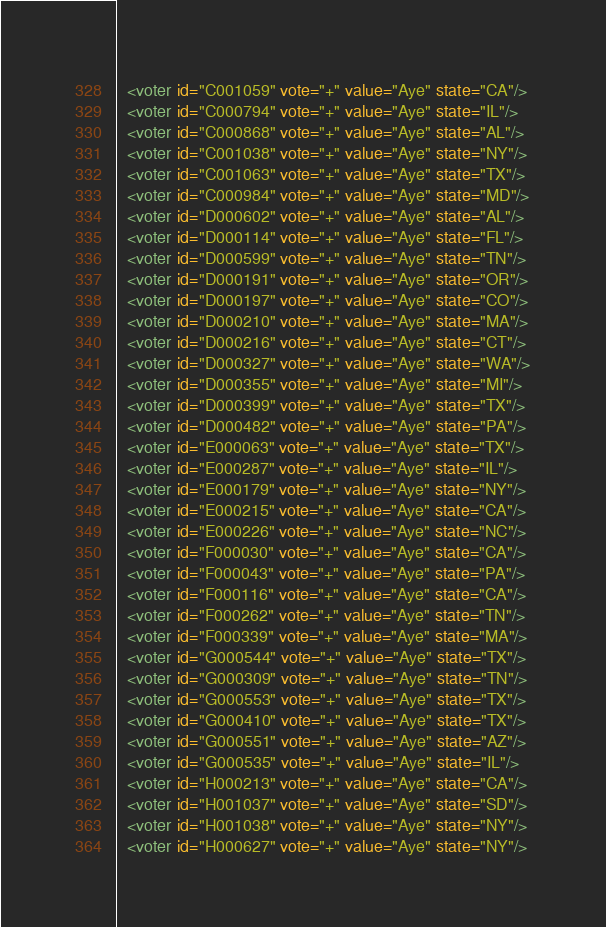Convert code to text. <code><loc_0><loc_0><loc_500><loc_500><_XML_>  <voter id="C001059" vote="+" value="Aye" state="CA"/>
  <voter id="C000794" vote="+" value="Aye" state="IL"/>
  <voter id="C000868" vote="+" value="Aye" state="AL"/>
  <voter id="C001038" vote="+" value="Aye" state="NY"/>
  <voter id="C001063" vote="+" value="Aye" state="TX"/>
  <voter id="C000984" vote="+" value="Aye" state="MD"/>
  <voter id="D000602" vote="+" value="Aye" state="AL"/>
  <voter id="D000114" vote="+" value="Aye" state="FL"/>
  <voter id="D000599" vote="+" value="Aye" state="TN"/>
  <voter id="D000191" vote="+" value="Aye" state="OR"/>
  <voter id="D000197" vote="+" value="Aye" state="CO"/>
  <voter id="D000210" vote="+" value="Aye" state="MA"/>
  <voter id="D000216" vote="+" value="Aye" state="CT"/>
  <voter id="D000327" vote="+" value="Aye" state="WA"/>
  <voter id="D000355" vote="+" value="Aye" state="MI"/>
  <voter id="D000399" vote="+" value="Aye" state="TX"/>
  <voter id="D000482" vote="+" value="Aye" state="PA"/>
  <voter id="E000063" vote="+" value="Aye" state="TX"/>
  <voter id="E000287" vote="+" value="Aye" state="IL"/>
  <voter id="E000179" vote="+" value="Aye" state="NY"/>
  <voter id="E000215" vote="+" value="Aye" state="CA"/>
  <voter id="E000226" vote="+" value="Aye" state="NC"/>
  <voter id="F000030" vote="+" value="Aye" state="CA"/>
  <voter id="F000043" vote="+" value="Aye" state="PA"/>
  <voter id="F000116" vote="+" value="Aye" state="CA"/>
  <voter id="F000262" vote="+" value="Aye" state="TN"/>
  <voter id="F000339" vote="+" value="Aye" state="MA"/>
  <voter id="G000544" vote="+" value="Aye" state="TX"/>
  <voter id="G000309" vote="+" value="Aye" state="TN"/>
  <voter id="G000553" vote="+" value="Aye" state="TX"/>
  <voter id="G000410" vote="+" value="Aye" state="TX"/>
  <voter id="G000551" vote="+" value="Aye" state="AZ"/>
  <voter id="G000535" vote="+" value="Aye" state="IL"/>
  <voter id="H000213" vote="+" value="Aye" state="CA"/>
  <voter id="H001037" vote="+" value="Aye" state="SD"/>
  <voter id="H001038" vote="+" value="Aye" state="NY"/>
  <voter id="H000627" vote="+" value="Aye" state="NY"/></code> 